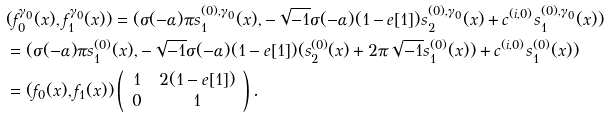<formula> <loc_0><loc_0><loc_500><loc_500>& ( f ^ { \gamma _ { 0 } } _ { 0 } ( x ) , f ^ { \gamma _ { 0 } } _ { 1 } ( x ) ) = ( \sigma ( - \alpha ) \pi s ^ { ( 0 ) , \gamma _ { 0 } } _ { 1 } ( x ) , - \sqrt { - 1 } \sigma ( - \alpha ) ( 1 - e [ 1 ] ) s ^ { ( 0 ) , \gamma _ { 0 } } _ { 2 } ( x ) + c ^ { ( i , 0 ) } s ^ { ( 0 ) , \gamma _ { 0 } } _ { 1 } ( x ) ) \\ & = ( \sigma ( - \alpha ) \pi s ^ { ( 0 ) } _ { 1 } ( x ) , - \sqrt { - 1 } \sigma ( - \alpha ) ( 1 - e [ 1 ] ) ( s ^ { ( 0 ) } _ { 2 } ( x ) + 2 \pi \sqrt { - 1 } s ^ { ( 0 ) } _ { 1 } ( x ) ) + c ^ { ( i , 0 ) } s ^ { ( 0 ) } _ { 1 } ( x ) ) \\ & = ( f _ { 0 } ( x ) , f _ { 1 } ( x ) ) \left ( \begin{array} { c c } 1 & 2 ( 1 - e [ 1 ] ) \\ 0 & 1 \end{array} \right ) .</formula> 